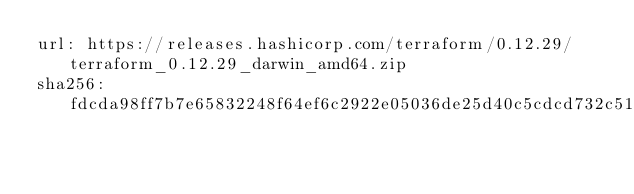Convert code to text. <code><loc_0><loc_0><loc_500><loc_500><_YAML_>url: https://releases.hashicorp.com/terraform/0.12.29/terraform_0.12.29_darwin_amd64.zip
sha256: fdcda98ff7b7e65832248f64ef6c2922e05036de25d40c5cdcd732c5117150aa
</code> 